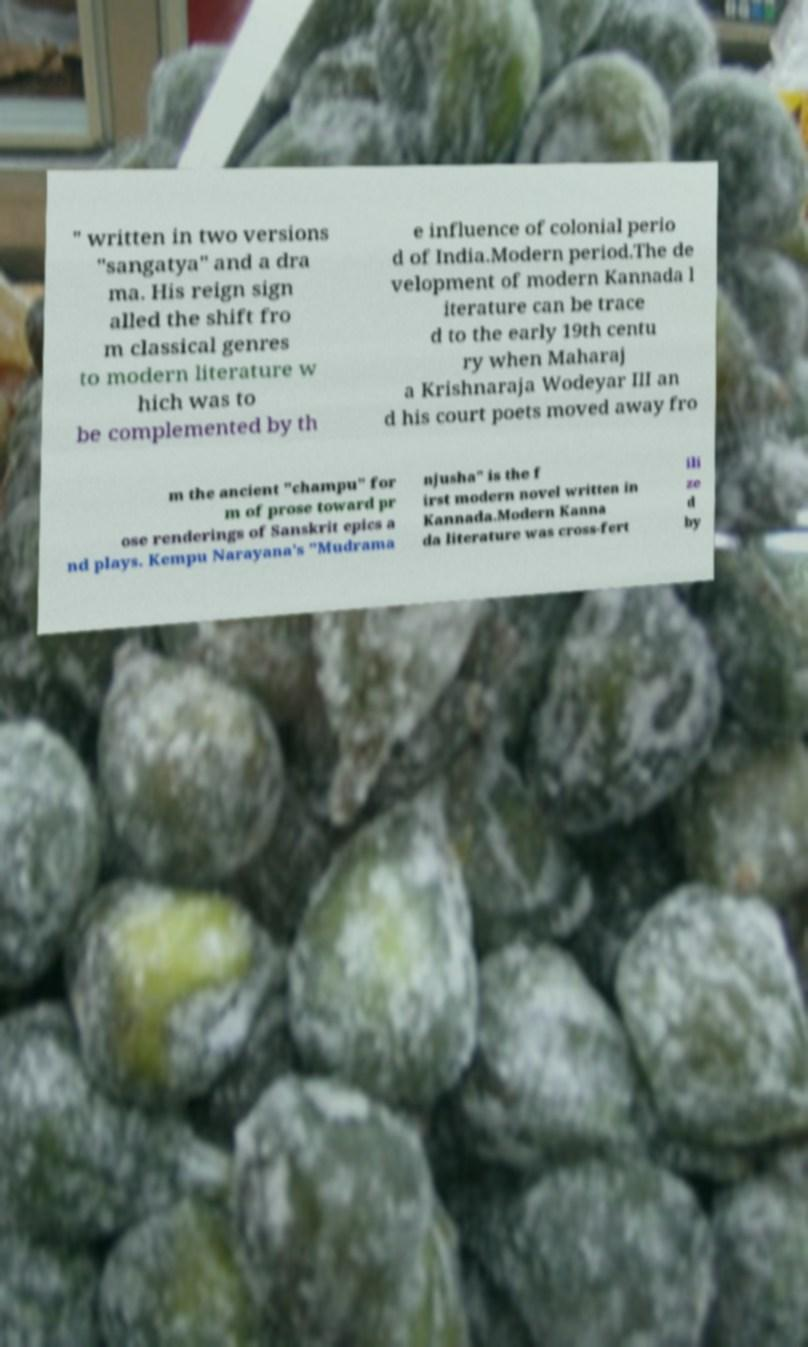Could you assist in decoding the text presented in this image and type it out clearly? " written in two versions "sangatya" and a dra ma. His reign sign alled the shift fro m classical genres to modern literature w hich was to be complemented by th e influence of colonial perio d of India.Modern period.The de velopment of modern Kannada l iterature can be trace d to the early 19th centu ry when Maharaj a Krishnaraja Wodeyar III an d his court poets moved away fro m the ancient "champu" for m of prose toward pr ose renderings of Sanskrit epics a nd plays. Kempu Narayana's "Mudrama njusha" is the f irst modern novel written in Kannada.Modern Kanna da literature was cross-fert ili ze d by 